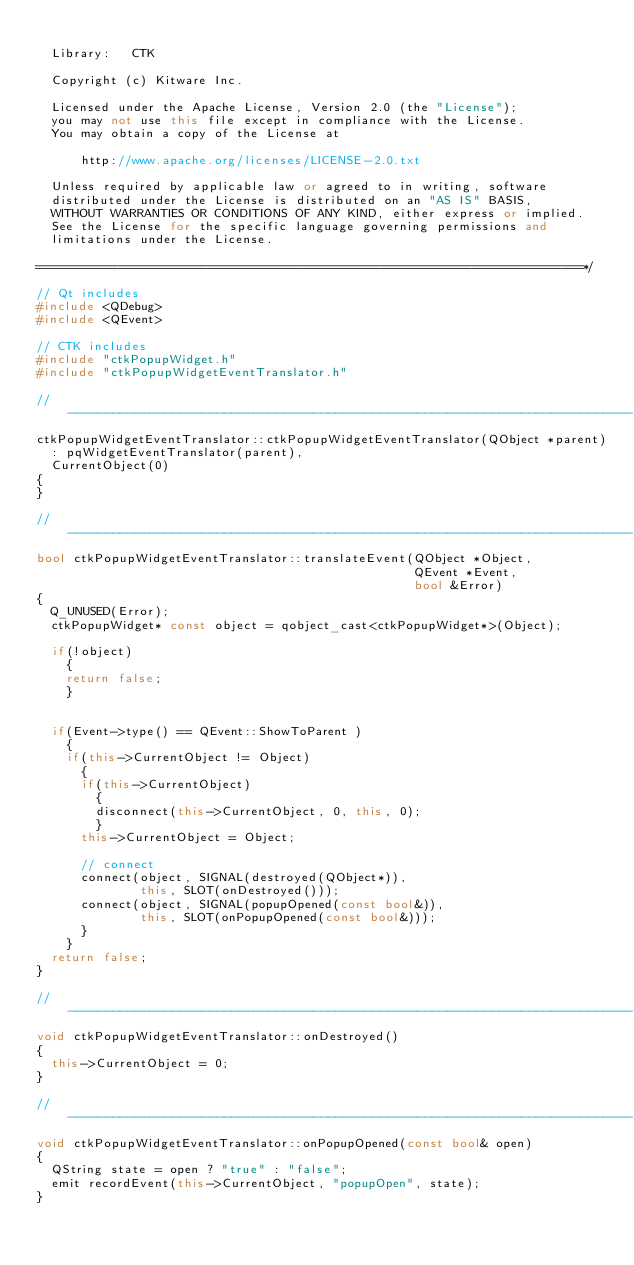Convert code to text. <code><loc_0><loc_0><loc_500><loc_500><_C++_>
  Library:   CTK

  Copyright (c) Kitware Inc.

  Licensed under the Apache License, Version 2.0 (the "License");
  you may not use this file except in compliance with the License.
  You may obtain a copy of the License at

      http://www.apache.org/licenses/LICENSE-2.0.txt

  Unless required by applicable law or agreed to in writing, software
  distributed under the License is distributed on an "AS IS" BASIS,
  WITHOUT WARRANTIES OR CONDITIONS OF ANY KIND, either express or implied.
  See the License for the specific language governing permissions and
  limitations under the License.

=========================================================================*/

// Qt includes
#include <QDebug>
#include <QEvent>

// CTK includes
#include "ctkPopupWidget.h"
#include "ctkPopupWidgetEventTranslator.h"

// ----------------------------------------------------------------------------
ctkPopupWidgetEventTranslator::ctkPopupWidgetEventTranslator(QObject *parent)
  : pqWidgetEventTranslator(parent),
  CurrentObject(0)
{
}

// ----------------------------------------------------------------------------
bool ctkPopupWidgetEventTranslator::translateEvent(QObject *Object,
                                                   QEvent *Event,
                                                   bool &Error)
{
  Q_UNUSED(Error);
  ctkPopupWidget* const object = qobject_cast<ctkPopupWidget*>(Object);

  if(!object)
    {
    return false;
    }


  if(Event->type() == QEvent::ShowToParent )
    {
    if(this->CurrentObject != Object)
      {
      if(this->CurrentObject)
        {
        disconnect(this->CurrentObject, 0, this, 0);
        }
      this->CurrentObject = Object;

      // connect
      connect(object, SIGNAL(destroyed(QObject*)),
              this, SLOT(onDestroyed()));
      connect(object, SIGNAL(popupOpened(const bool&)),
              this, SLOT(onPopupOpened(const bool&)));
      }
    }
  return false;
}

// ----------------------------------------------------------------------------
void ctkPopupWidgetEventTranslator::onDestroyed()
{
  this->CurrentObject = 0;
}

// ----------------------------------------------------------------------------
void ctkPopupWidgetEventTranslator::onPopupOpened(const bool& open)
{
  QString state = open ? "true" : "false";
  emit recordEvent(this->CurrentObject, "popupOpen", state);
}


</code> 